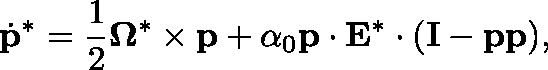Convert formula to latex. <formula><loc_0><loc_0><loc_500><loc_500>\dot { p } ^ { * } = \frac { 1 } { 2 } \Omega ^ { * } \times p + \alpha _ { 0 } p \cdot E ^ { * } \cdot ( I - p p ) ,</formula> 